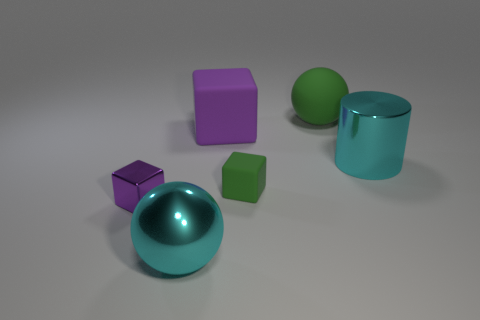Subtract all big blocks. How many blocks are left? 2 Add 3 large cyan cylinders. How many objects exist? 9 Subtract all green balls. How many balls are left? 1 Subtract all spheres. How many objects are left? 4 Subtract 1 blocks. How many blocks are left? 2 Subtract all gray balls. Subtract all cyan cylinders. How many balls are left? 2 Subtract all red cylinders. How many purple cubes are left? 2 Subtract all green rubber spheres. Subtract all cyan metal spheres. How many objects are left? 4 Add 5 tiny green things. How many tiny green things are left? 6 Add 6 big red shiny blocks. How many big red shiny blocks exist? 6 